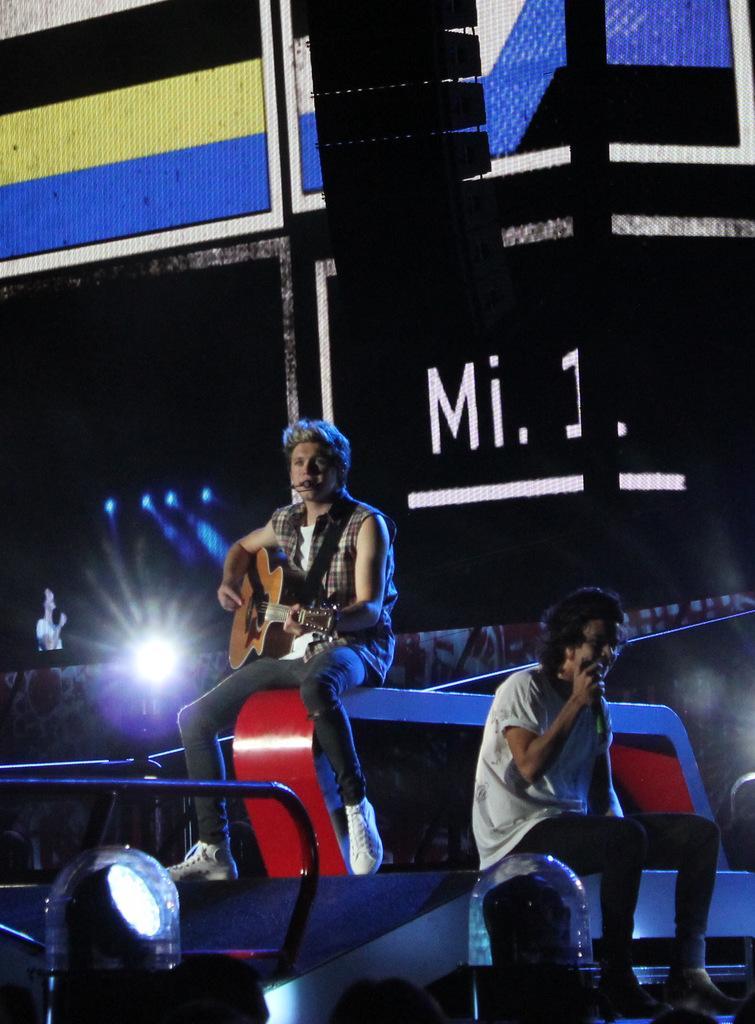Can you describe this image briefly? In this image I can see two people are sitting and one of them is holding a guitar. I can also see few lights and a screen. 